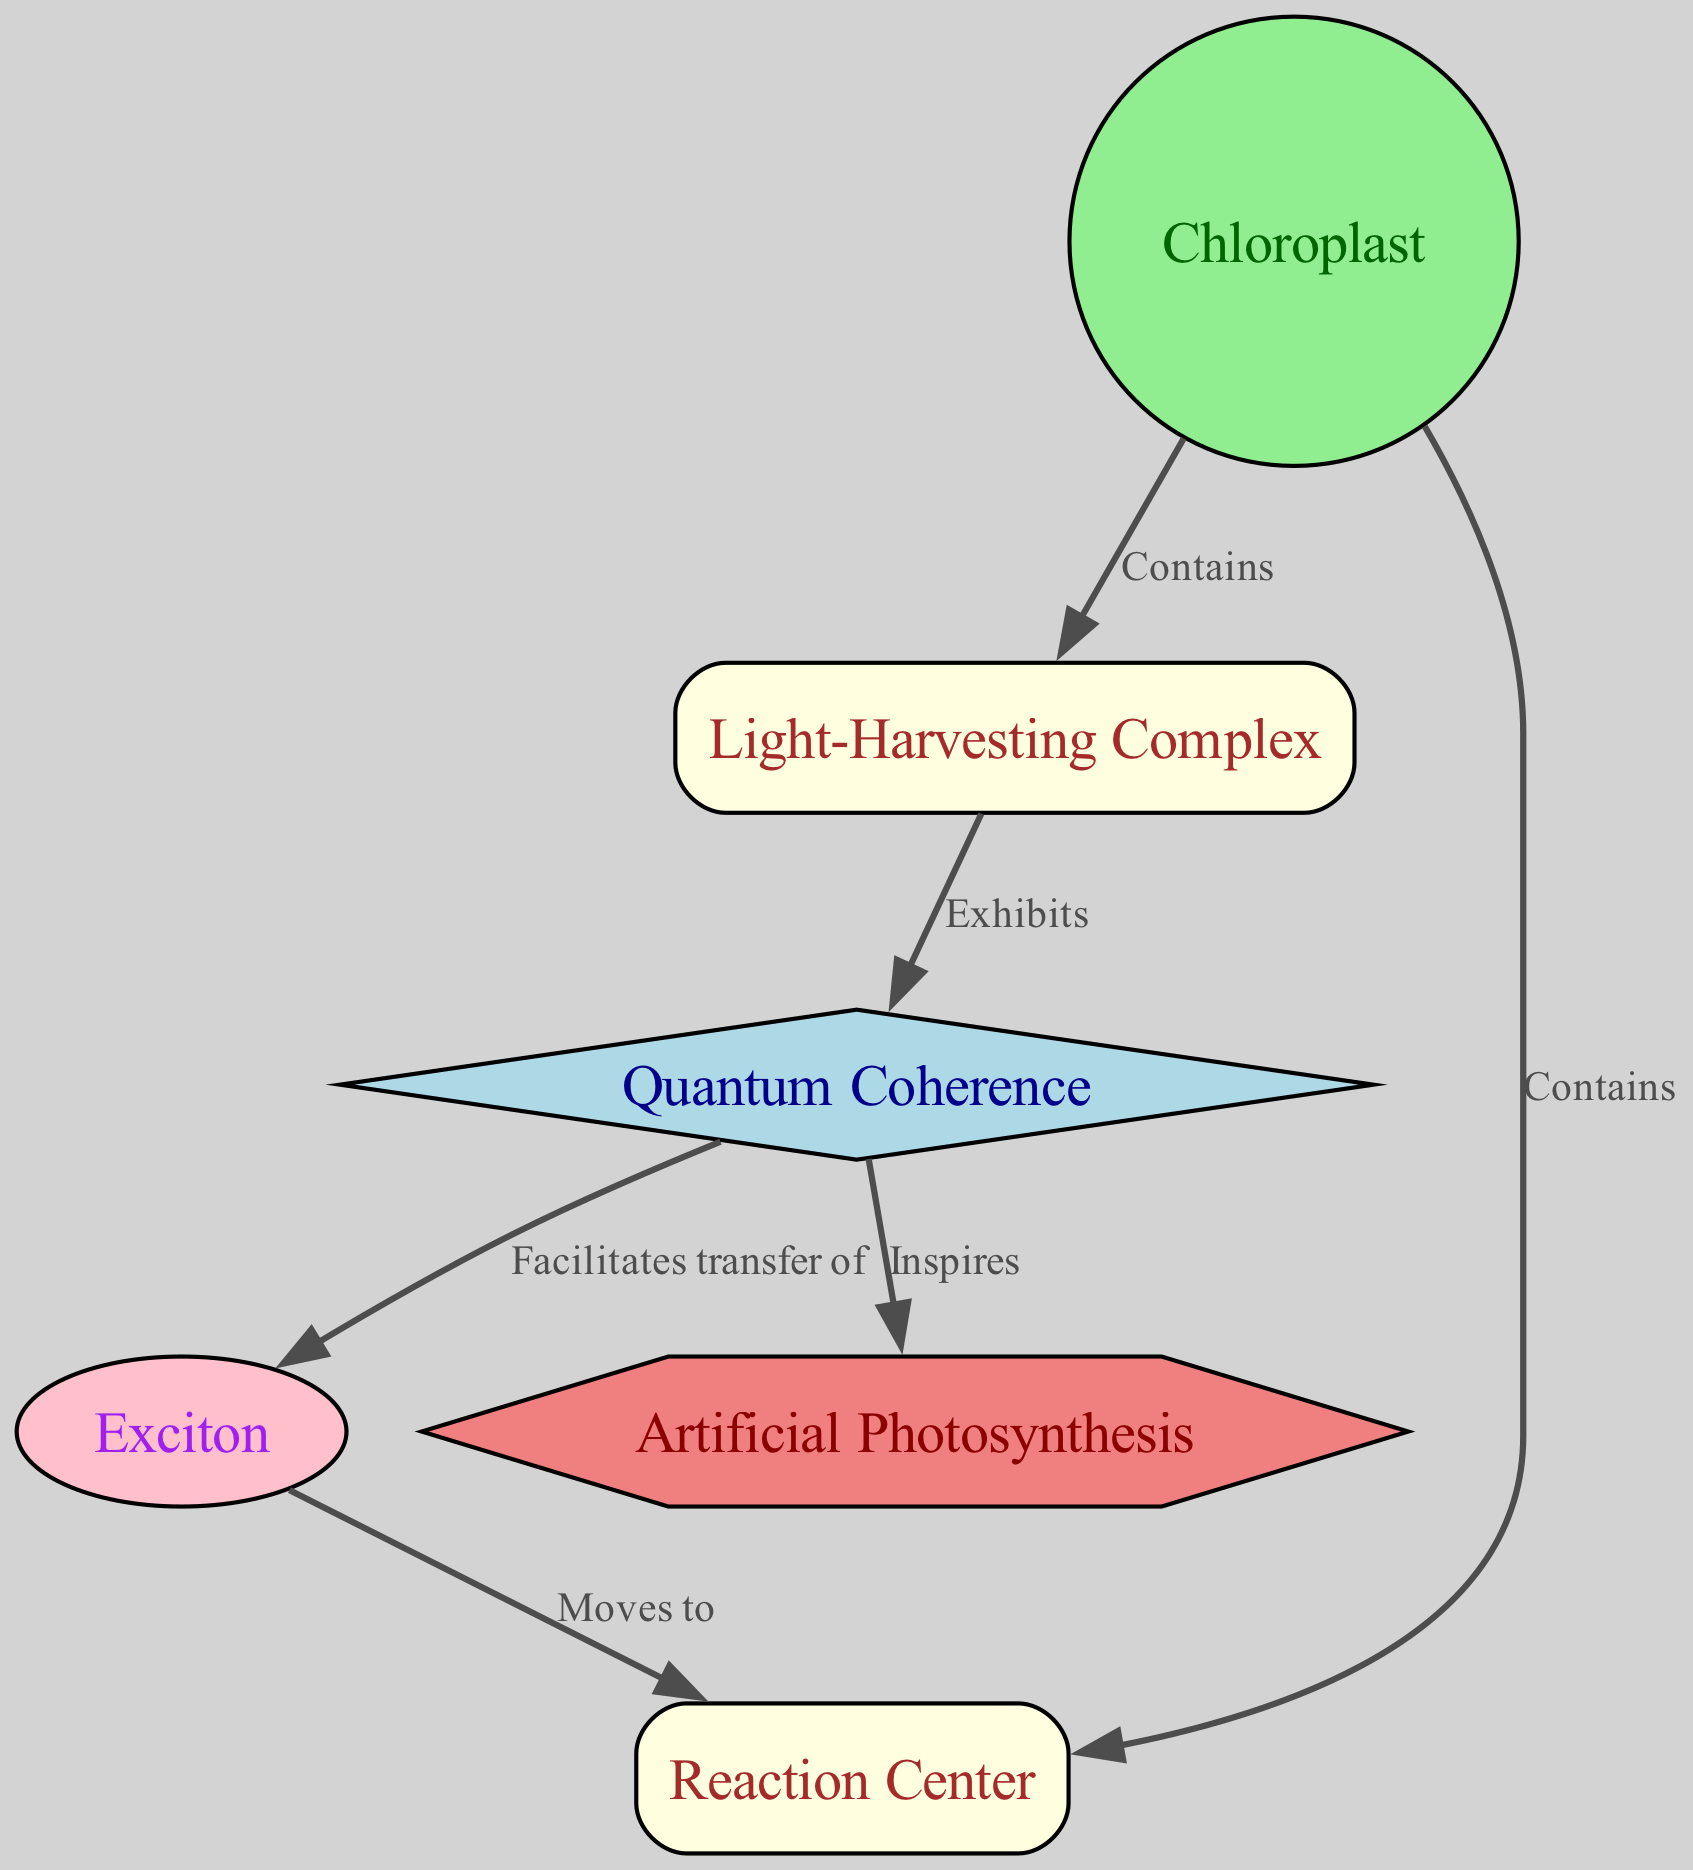What type is the "Reaction Center"? Referring to the diagram, the "Reaction Center" node is categorized as a protein, which is indicated by its designated type in the graphic.
Answer: protein How many nodes are depicted in the diagram? By counting the individual nodes in the diagram, we can see there are six distinct nodes: Chloroplast, Light-Harvesting Complex, Reaction Center, Quantum Coherence, Exciton, and Artificial Photosynthesis.
Answer: 6 What does "Quantum Coherence" facilitate the transfer of? Following the edge that connects "Quantum Coherence" to "Exciton", we find that the label indicates it facilitates the transfer of excitons, demonstrating its role in the process.
Answer: exciton Which node is inspired by "Quantum Coherence"? The edge from "Quantum Coherence" to "Artificial Photosynthesis" reveals that this phenomenon inspires the development of artificial photosynthesis technologies.
Answer: Artificial Photosynthesis What kind of edge connects "Light-Harvesting Complex" to "Quantum Coherence"? This edge has the label "Exhibits", which describes the relationship where the Light-Harvesting Complex exhibits the phenomenon of Quantum Coherence.
Answer: Exhibits How does exciton do to "Reaction Center"? The diagram shows an edge labeled "Moves to" which indicates the process where the exciton moves to the Reaction Center as part of energy transfer in photosynthesis.
Answer: Moves to What is the relationship between "Chloroplast" and "Light-Harvesting Complex"? There's a direct connection labeled "Contains", showing that the chloroplast contains the light-harvesting complex as part of its structure.
Answer: Contains What type of technology is "Artificial Photosynthesis"? The diagram defines "Artificial Photosynthesis" as a technology, highlighted by the shape and type associated with this node.
Answer: technology 